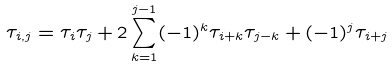<formula> <loc_0><loc_0><loc_500><loc_500>\tau _ { i , j } = \tau _ { i } \tau _ { j } + 2 \sum _ { k = 1 } ^ { j - 1 } ( - 1 ) ^ { k } \tau _ { i + k } \tau _ { j - k } + ( - 1 ) ^ { j } \tau _ { i + j }</formula> 